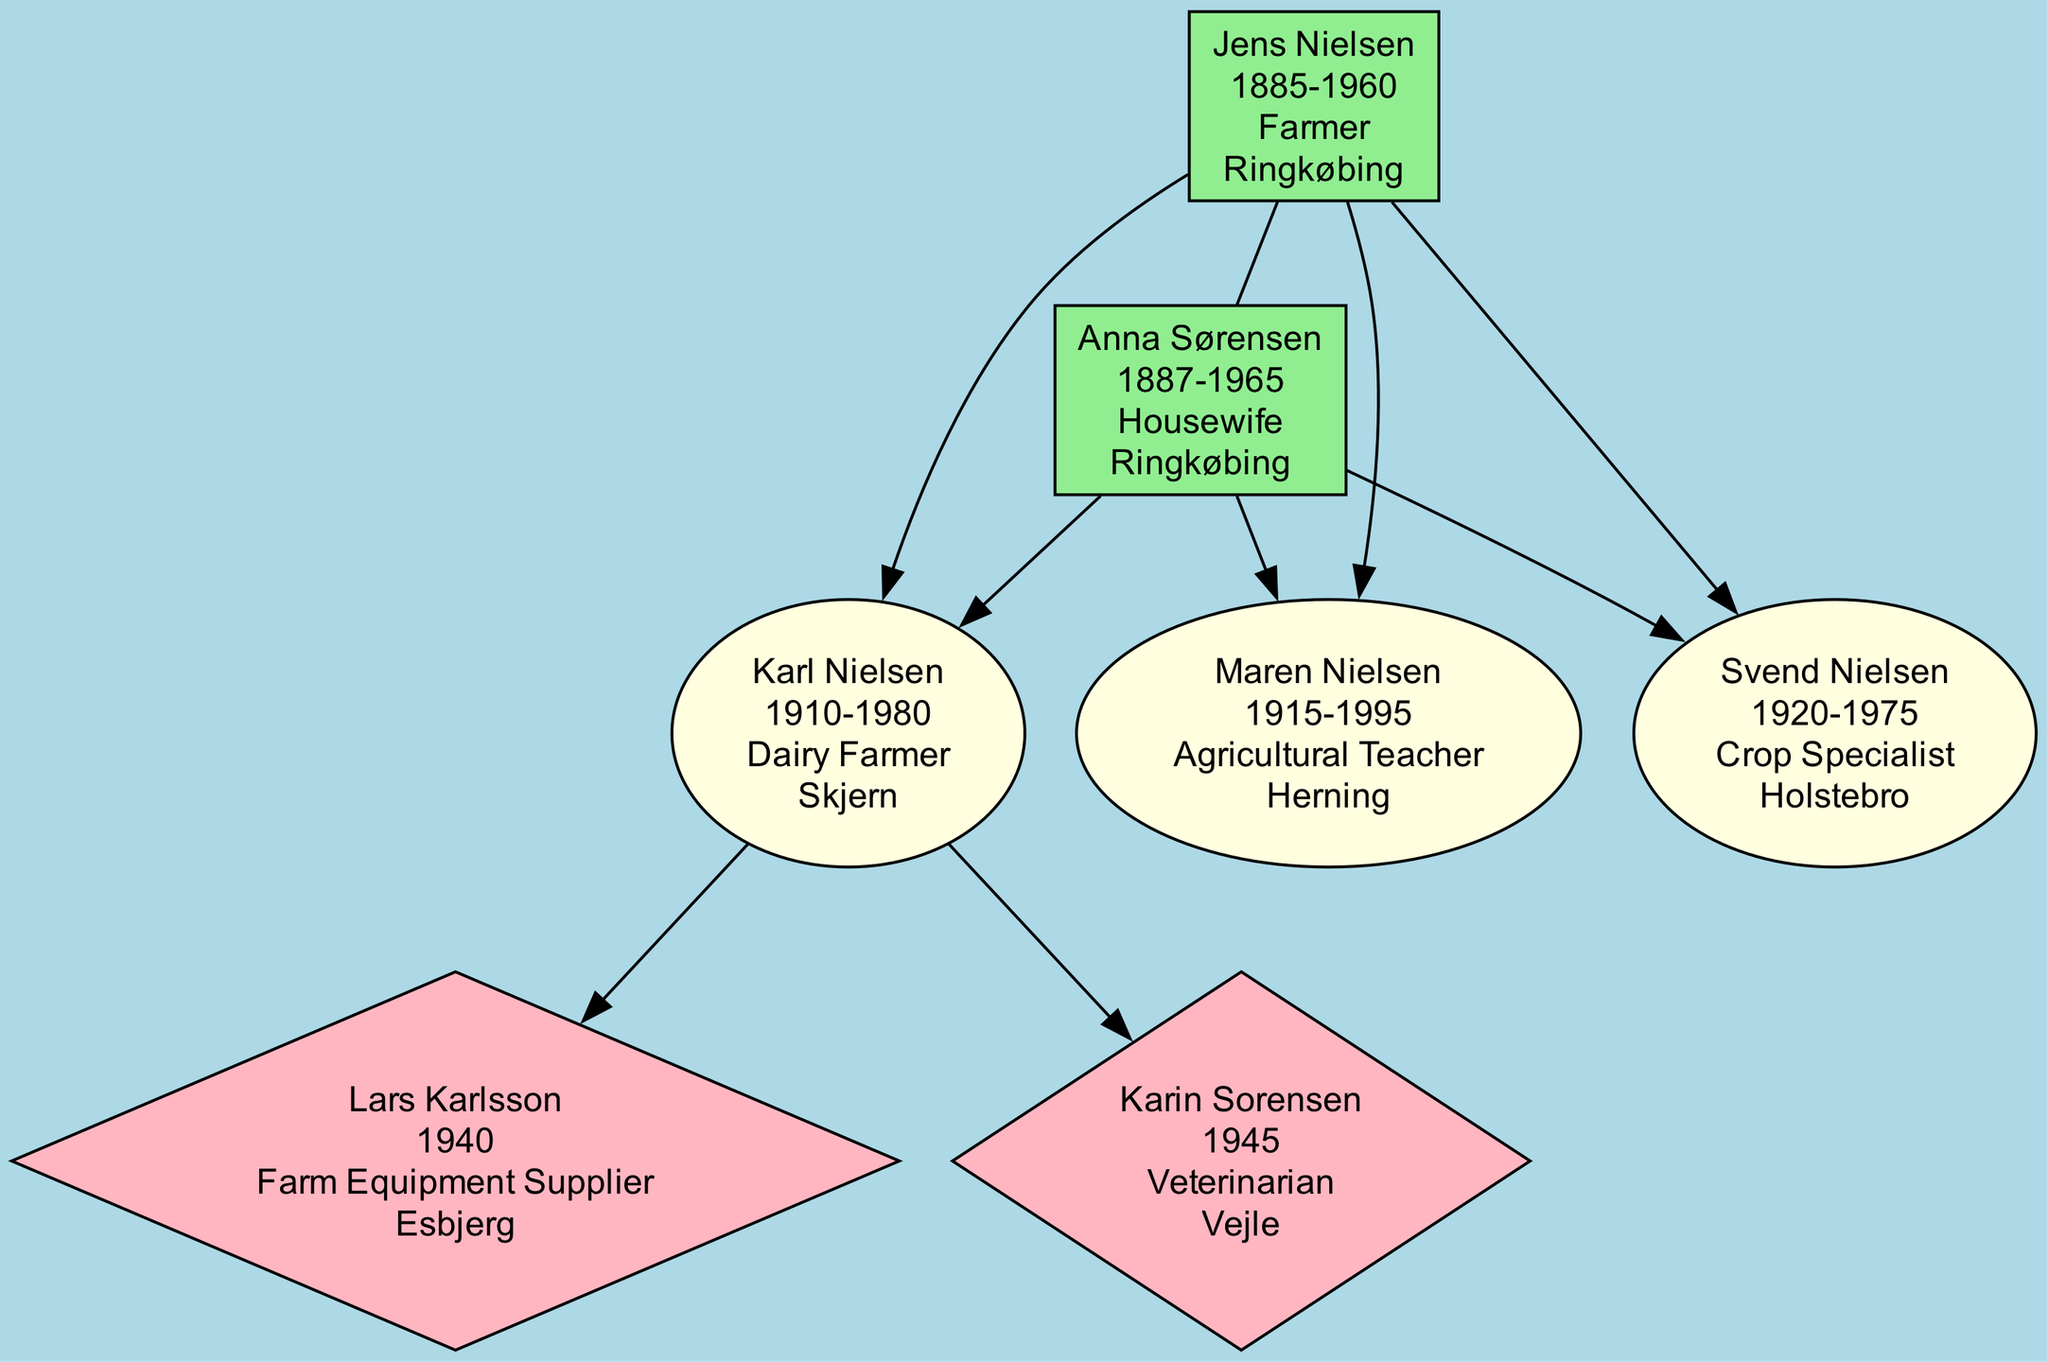What is the profession of Jens Nielsen? The profession of Jens Nielsen is listed in the diagram as "Farmer". This can be identified directly from the node representing him.
Answer: Farmer How many children did Jens and Anna have? By counting the nodes under the patriarch and matriarch in the diagram, there are three children shown connecting to them.
Answer: 3 What was the influence of Maren Nielsen? The influence of Maren Nielsen is described in her node as "Educated future generations of farmers in modern agricultural techniques". This information can be found directly beneath her name.
Answer: Educated future generations of farmers in modern agricultural techniques Who supplied the latest farming equipment to regional farms? The influence node for Lars Karlsson states that he "Supplied latest farming equipment to regional farms". Thus, by checking his node we find the answer.
Answer: Lars Karlsson Which child was a crop specialist? Svend Nielsen's node indicates his profession as "Crop Specialist". Therefore, by locating his node in the diagram, one can readily ascertain the answer.
Answer: Svend Nielsen What year did Anna Sørensen pass away? The year of death for Anna Sørensen is specified in her node as 1965. This is stated directly in the diagram associated with her name.
Answer: 1965 How many grandchildren are there in total? By counting the grandchildren nodes in the diagram, there are two listed: Lars Karlsson and Karin Sorensen. This information can be derived from examining the shapes at the grandchildren level.
Answer: 2 What profession did Karin Sorensen have? The node for Karin Sorensen specifically mentions her profession as "Veterinarian", which is stated directly on her node.
Answer: Veterinarian Which locations are represented by the children? The locations for each child are given in their respective nodes. Karl Nielsen is from Skjern, Maren Nielsen from Herning, and Svend Nielsen from Holstebro. Therefore, the locations are derived by checking each child's node.
Answer: Skjern, Herning, Holstebro 